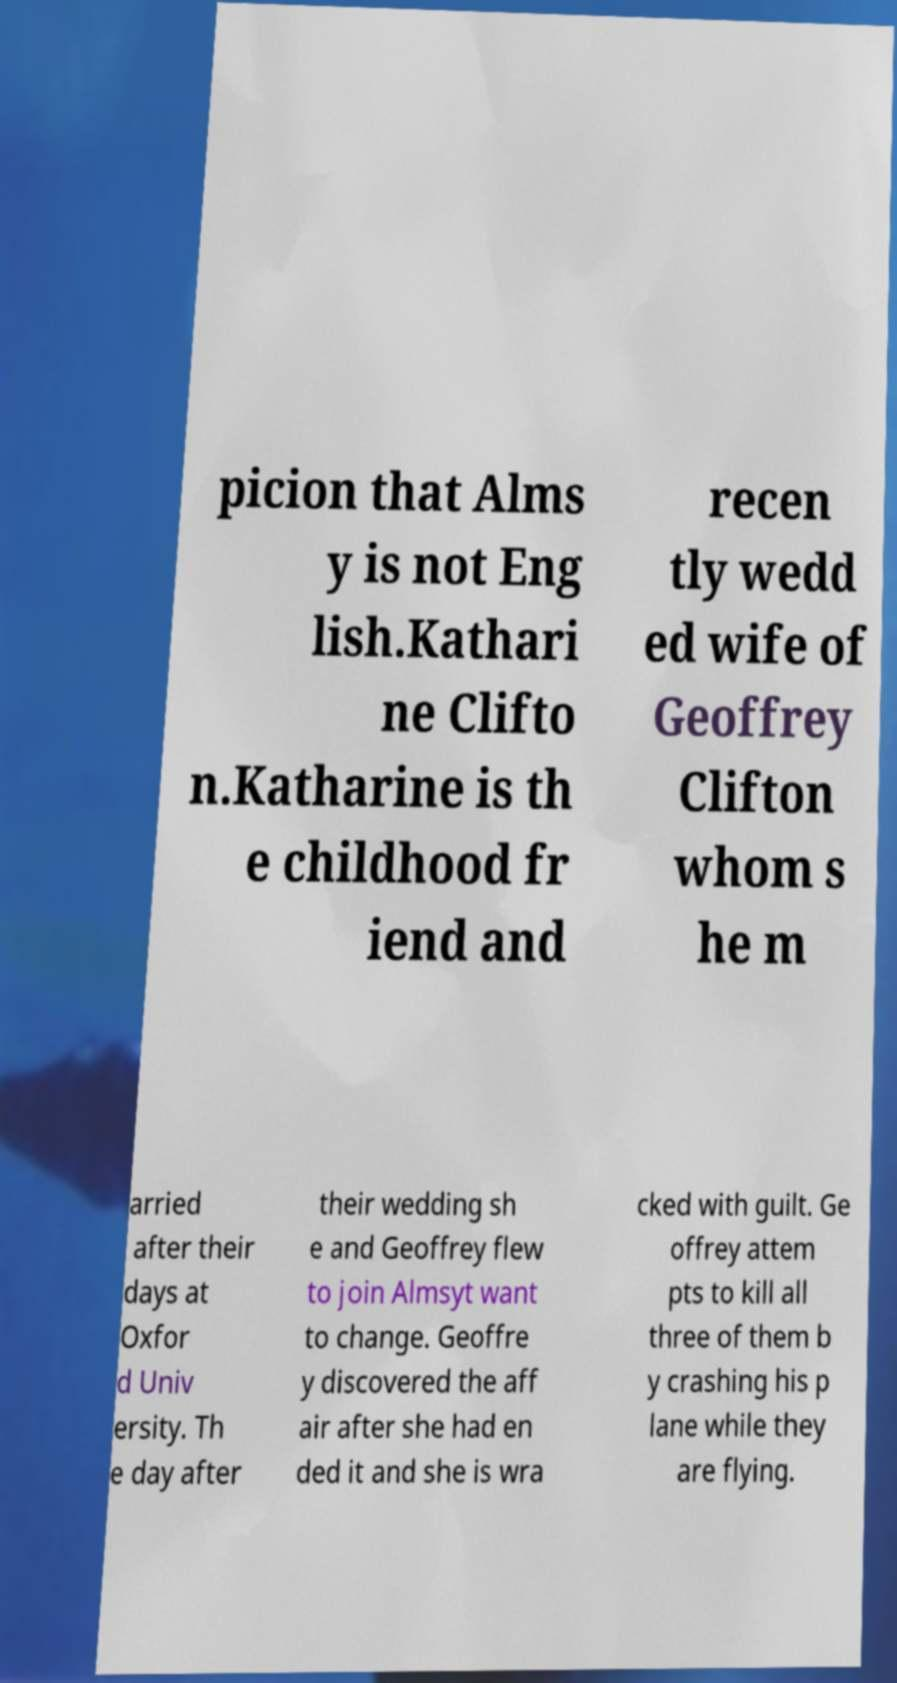Please read and relay the text visible in this image. What does it say? picion that Alms y is not Eng lish.Kathari ne Clifto n.Katharine is th e childhood fr iend and recen tly wedd ed wife of Geoffrey Clifton whom s he m arried after their days at Oxfor d Univ ersity. Th e day after their wedding sh e and Geoffrey flew to join Almsyt want to change. Geoffre y discovered the aff air after she had en ded it and she is wra cked with guilt. Ge offrey attem pts to kill all three of them b y crashing his p lane while they are flying. 